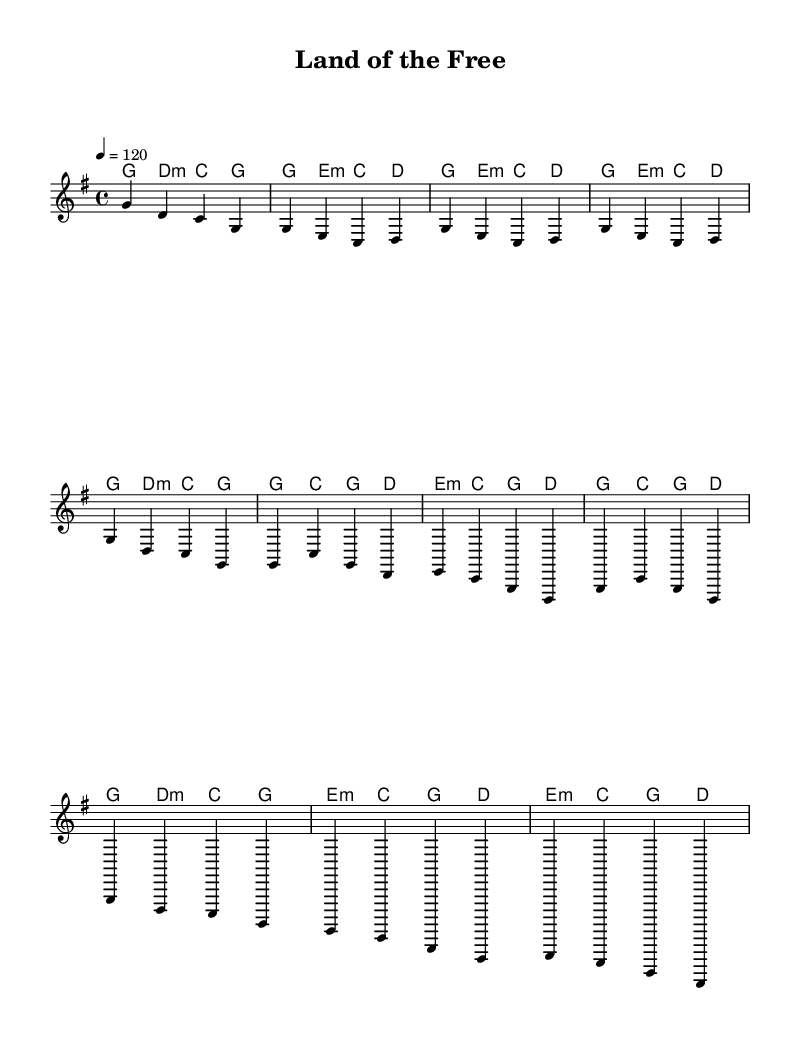What is the key signature of this music? The key signature is G major, which has one sharp (F#). This can be determined by examining the key signature notation at the beginning of the score.
Answer: G major What is the time signature of this music? The time signature is 4/4, indicated at the beginning of the score. This means there are four beats per measure and a quarter note gets one beat.
Answer: 4/4 What is the tempo marking of this piece? The tempo marking is 120 beats per minute. This is specified in the tempo section of the score where it indicates the speed of the music.
Answer: 120 How many measures are in the chorus? The chorus consists of four measures as indicated by the group of notes and corresponding lyrics, which follow after the verse and are structured similarly.
Answer: 4 What chord is played in the second measure of the verse? The second measure of the verse features the E minor chord as indicated in the harmonies section. Each measure can be examined to identify the chord notated for that particular measure.
Answer: E minor What lyrical theme is prevalent in this country rock anthem? The lyrical theme focuses on patriotism and pride in American values, as expressed through phrases about unity and freedom found throughout the lyrics. This can be understood by analyzing the content of the lyrics provided.
Answer: Patriotism Which section of the music contains the bridge? The bridge is found immediately after the chorus, clearly marked by its unique lyrics and a shift in musical pattern, which can be identified by analyzing the structure of the piece.
Answer: After the chorus 